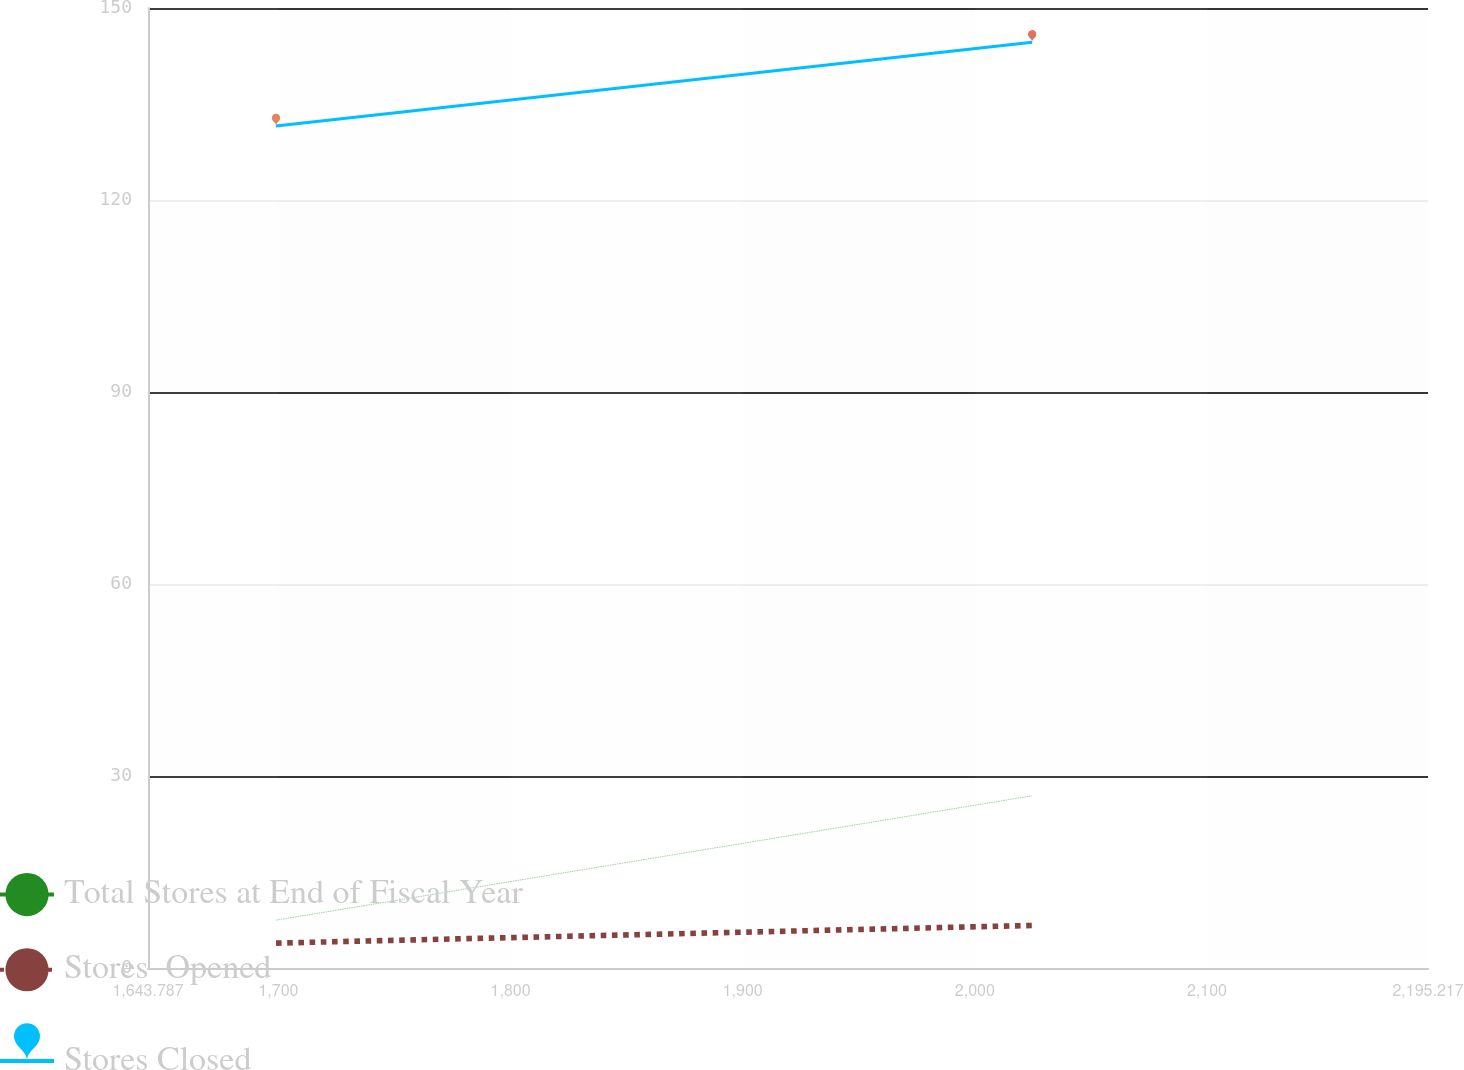Convert chart. <chart><loc_0><loc_0><loc_500><loc_500><line_chart><ecel><fcel>Total Stores at End of Fiscal Year<fcel>Stores  Opened<fcel>Stores Closed<nl><fcel>1698.93<fcel>7.48<fcel>3.89<fcel>131.58<nl><fcel>2024.69<fcel>26.91<fcel>6.65<fcel>144.64<nl><fcel>2250.36<fcel>9.42<fcel>5.1<fcel>169.52<nl></chart> 